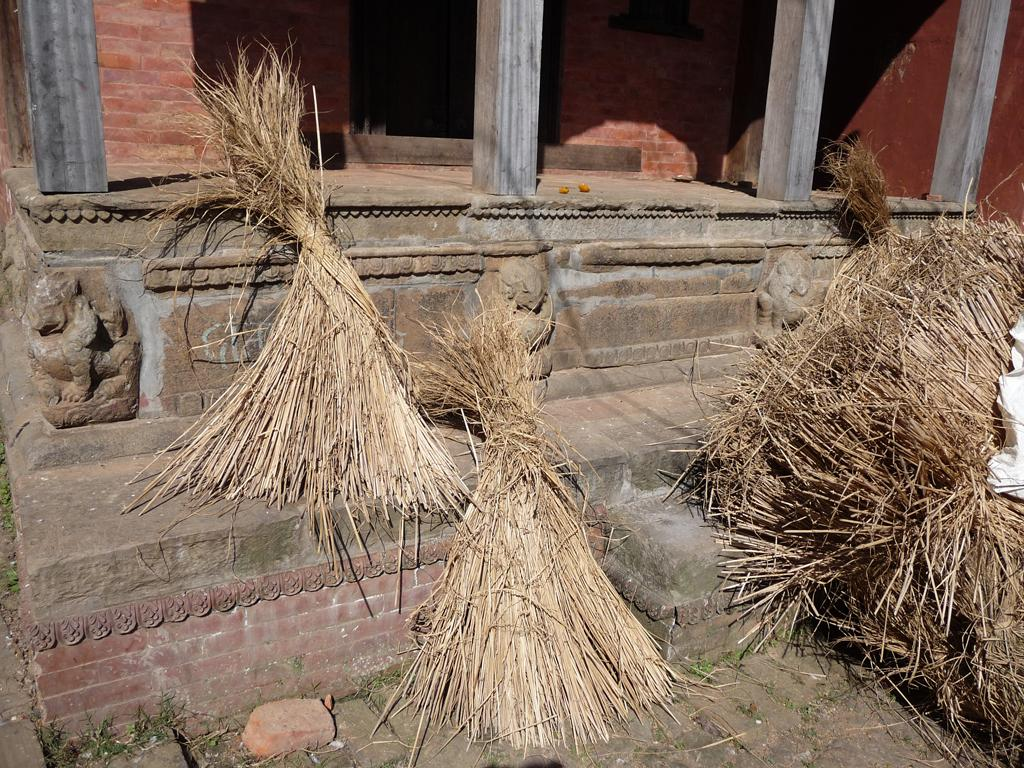What type of structure is present in the image? There is a building in the image. What are some features of the building? The building has doors, windows, and pillars. What can be seen in the foreground of the image? There is grass visible in the image. Are there any other objects present in the image? Yes, there is a brick and fodder in the image. What is the background of the image composed of? There is a wall in the image. What emotion is the building expressing in the image? Buildings do not express emotions; they are inanimate objects. 